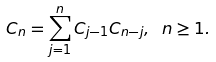Convert formula to latex. <formula><loc_0><loc_0><loc_500><loc_500>C _ { n } = \sum _ { j = 1 } ^ { n } C _ { j - 1 } C _ { n - j } , \ n \geq 1 .</formula> 